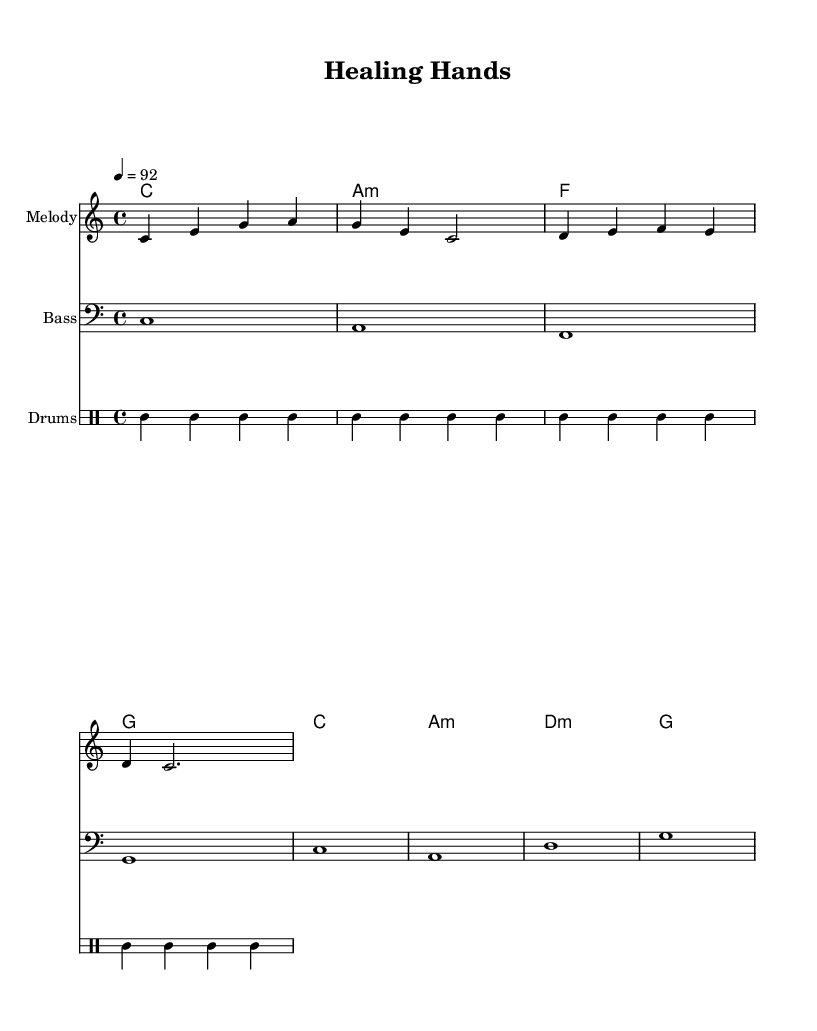What is the key signature of this music? The key signature is C major, which has no sharps or flats.
Answer: C major What is the time signature of this music? The time signature is indicated by the notation at the beginning of the score, which shows four beats per measure.
Answer: 4/4 What is the tempo marking for this piece? The tempo marking is located near the top of the score and indicates the speed of the music as 92 beats per minute.
Answer: 92 How many measures are in the melody part? By counting the vertical bar lines in the melody staff, we can see there are a total of four measures.
Answer: 4 What chords are used in the harmonies section? The chord names listed in the harmonies section include C, A minor, F, and G, which are standard in this musical style.
Answer: C, A minor, F, G How does the bassline relate to the harmonies? The bassline underpins the harmonies by playing the root notes of the chords, which enhances the harmonic structure and rhythm typical of hip hop music.
Answer: Root notes What is the role of the drums in this piece? The drums provide a rhythmic foundation and drive the beat forward, which is essential in hip hop music, enhancing the overall groove and feel of the piece.
Answer: Rhythmic foundation 